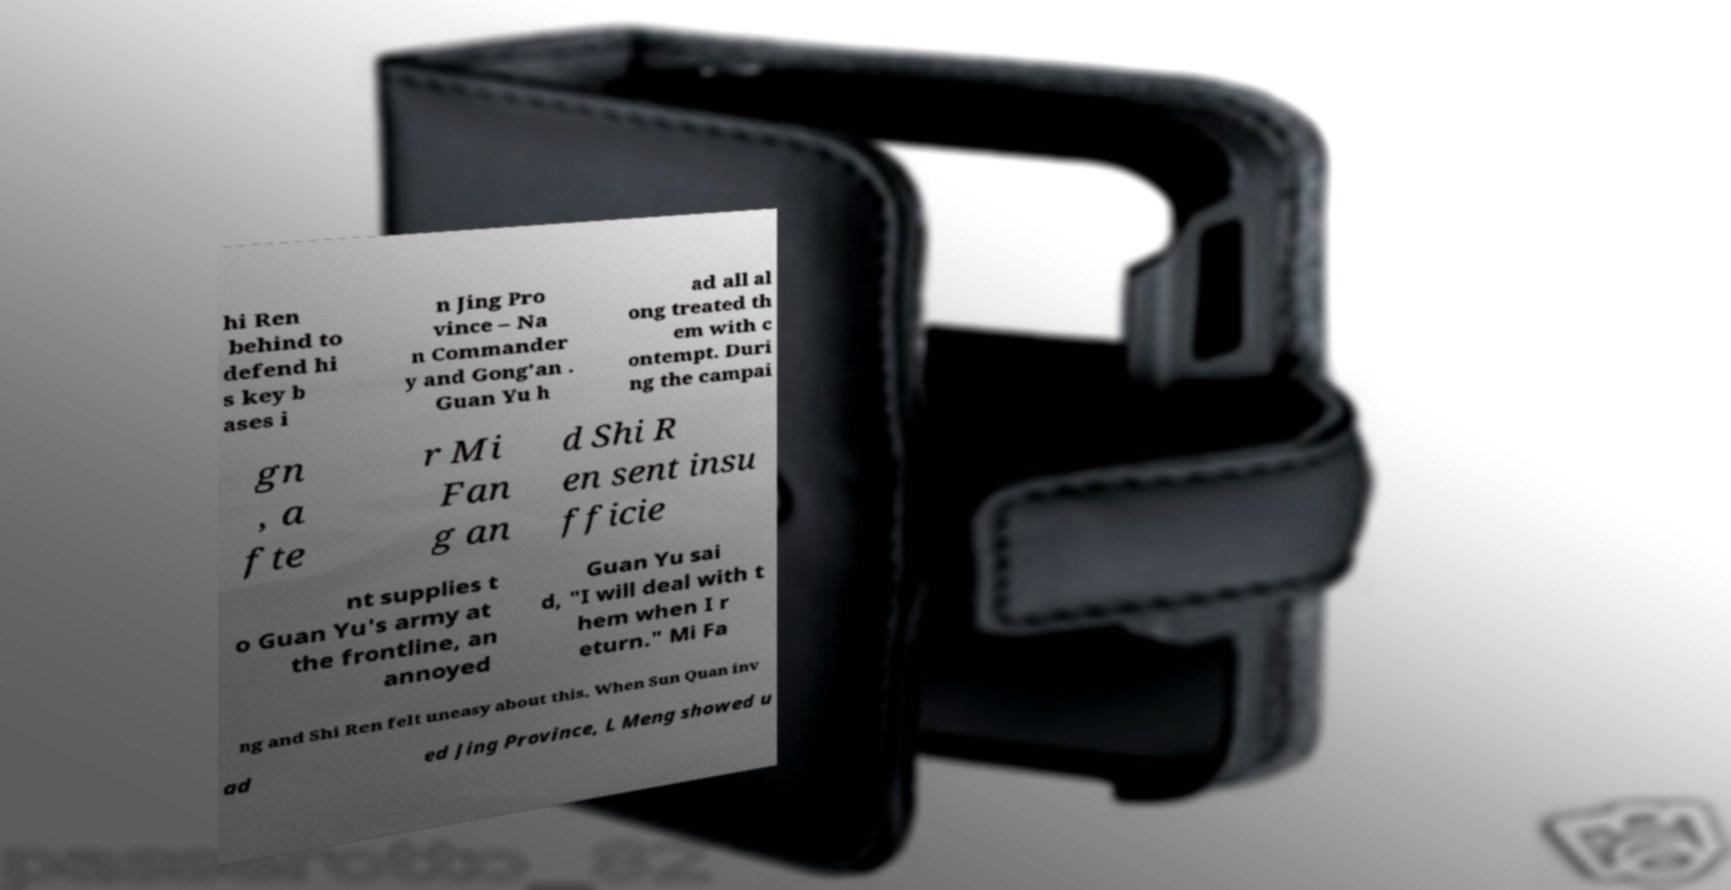There's text embedded in this image that I need extracted. Can you transcribe it verbatim? hi Ren behind to defend hi s key b ases i n Jing Pro vince – Na n Commander y and Gong'an . Guan Yu h ad all al ong treated th em with c ontempt. Duri ng the campai gn , a fte r Mi Fan g an d Shi R en sent insu fficie nt supplies t o Guan Yu's army at the frontline, an annoyed Guan Yu sai d, "I will deal with t hem when I r eturn." Mi Fa ng and Shi Ren felt uneasy about this. When Sun Quan inv ad ed Jing Province, L Meng showed u 